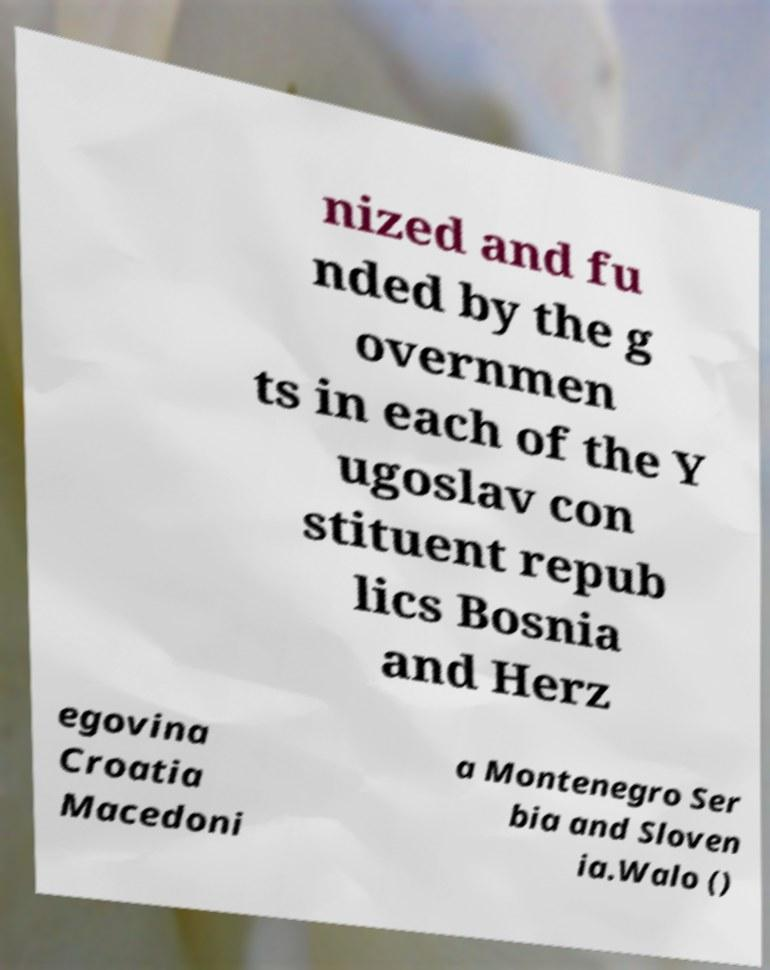What messages or text are displayed in this image? I need them in a readable, typed format. nized and fu nded by the g overnmen ts in each of the Y ugoslav con stituent repub lics Bosnia and Herz egovina Croatia Macedoni a Montenegro Ser bia and Sloven ia.Walo () 